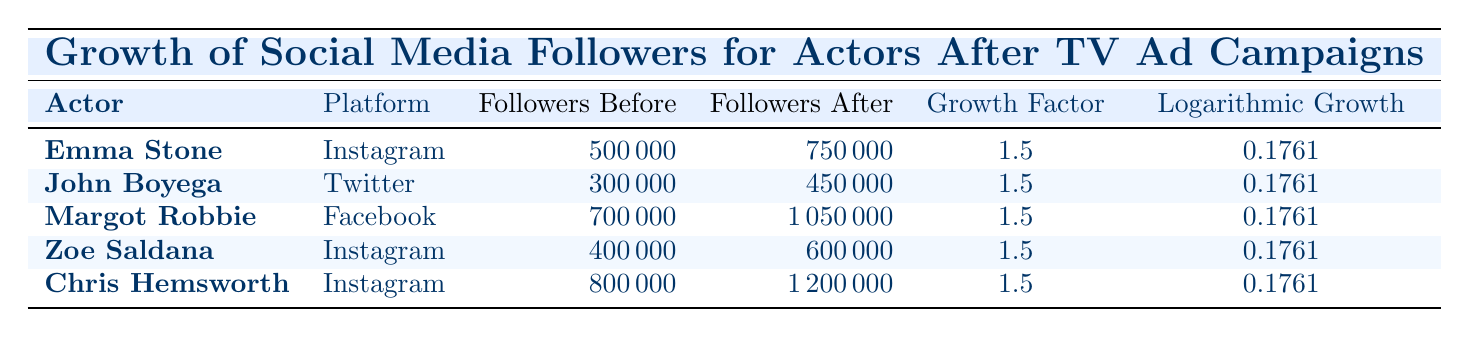What is the growth factor for Emma Stone on Instagram? The table lists the growth factor for each actor and their respective platforms. Looking at Emma Stone’s row, the growth factor is 1.5.
Answer: 1.5 How many followers did John Boyega have before the TV advertisement? To find out how many followers John Boyega had before the campaign, we can look at the "Followers Before" column for his entry. The value is 300,000.
Answer: 300000 Did Margot Robbie experience a growth in followers after the advertisement campaign? The "Followers After" entry for Margot Robbie is larger than the "Followers Before" entry, indicating that she did indeed experience growth in followers.
Answer: Yes What is the difference in followers for Zoe Saldana before and after the campaign? We need to subtract the number of followers before the campaign (400,000) from the number of followers after the campaign (600,000). So, 600,000 - 400,000 = 200,000.
Answer: 200000 What is the average number of followers before the TV ad campaigns for all actors listed? To calculate the average, sum the "Followers Before" counts: 500,000 + 300,000 + 700,000 + 400,000 + 800,000 = 2,700,000. There are 5 actors, so dividing by 5 gives us an average of 540,000.
Answer: 540000 Which actor gained the highest number of followers after the TV ad campaign? By comparing the "Followers After" values, we find Chris Hemsworth with 1,200,000 gained the most followers, as it is the largest value in that column.
Answer: Chris Hemsworth Is the logarithmic growth value the same for all actors listed? The table shows that all the entries in the "Logarithmic Growth" column share the same value of 0.1761, so yes, they are all identical.
Answer: Yes What was the total increase in followers for the actors on Instagram after the TV ad campaigns? Both Emma Stone and Zoe Saldana are on Instagram. The total increase can be calculated by summing their increases: (750,000 - 500,000) + (600,000 - 400,000) = 250,000 + 200,000 = 450,000.
Answer: 450000 What social media platform did John Boyega use? To answer this, we can look at John Boyega's row for the specific platform he used, which is Twitter.
Answer: Twitter 